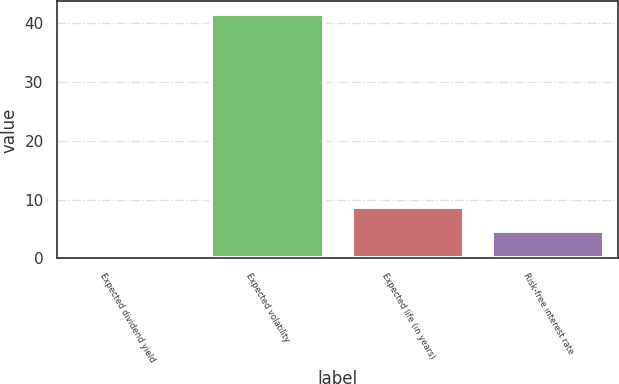Convert chart. <chart><loc_0><loc_0><loc_500><loc_500><bar_chart><fcel>Expected dividend yield<fcel>Expected volatility<fcel>Expected life (in years)<fcel>Risk-free interest rate<nl><fcel>0.61<fcel>41.61<fcel>8.81<fcel>4.71<nl></chart> 